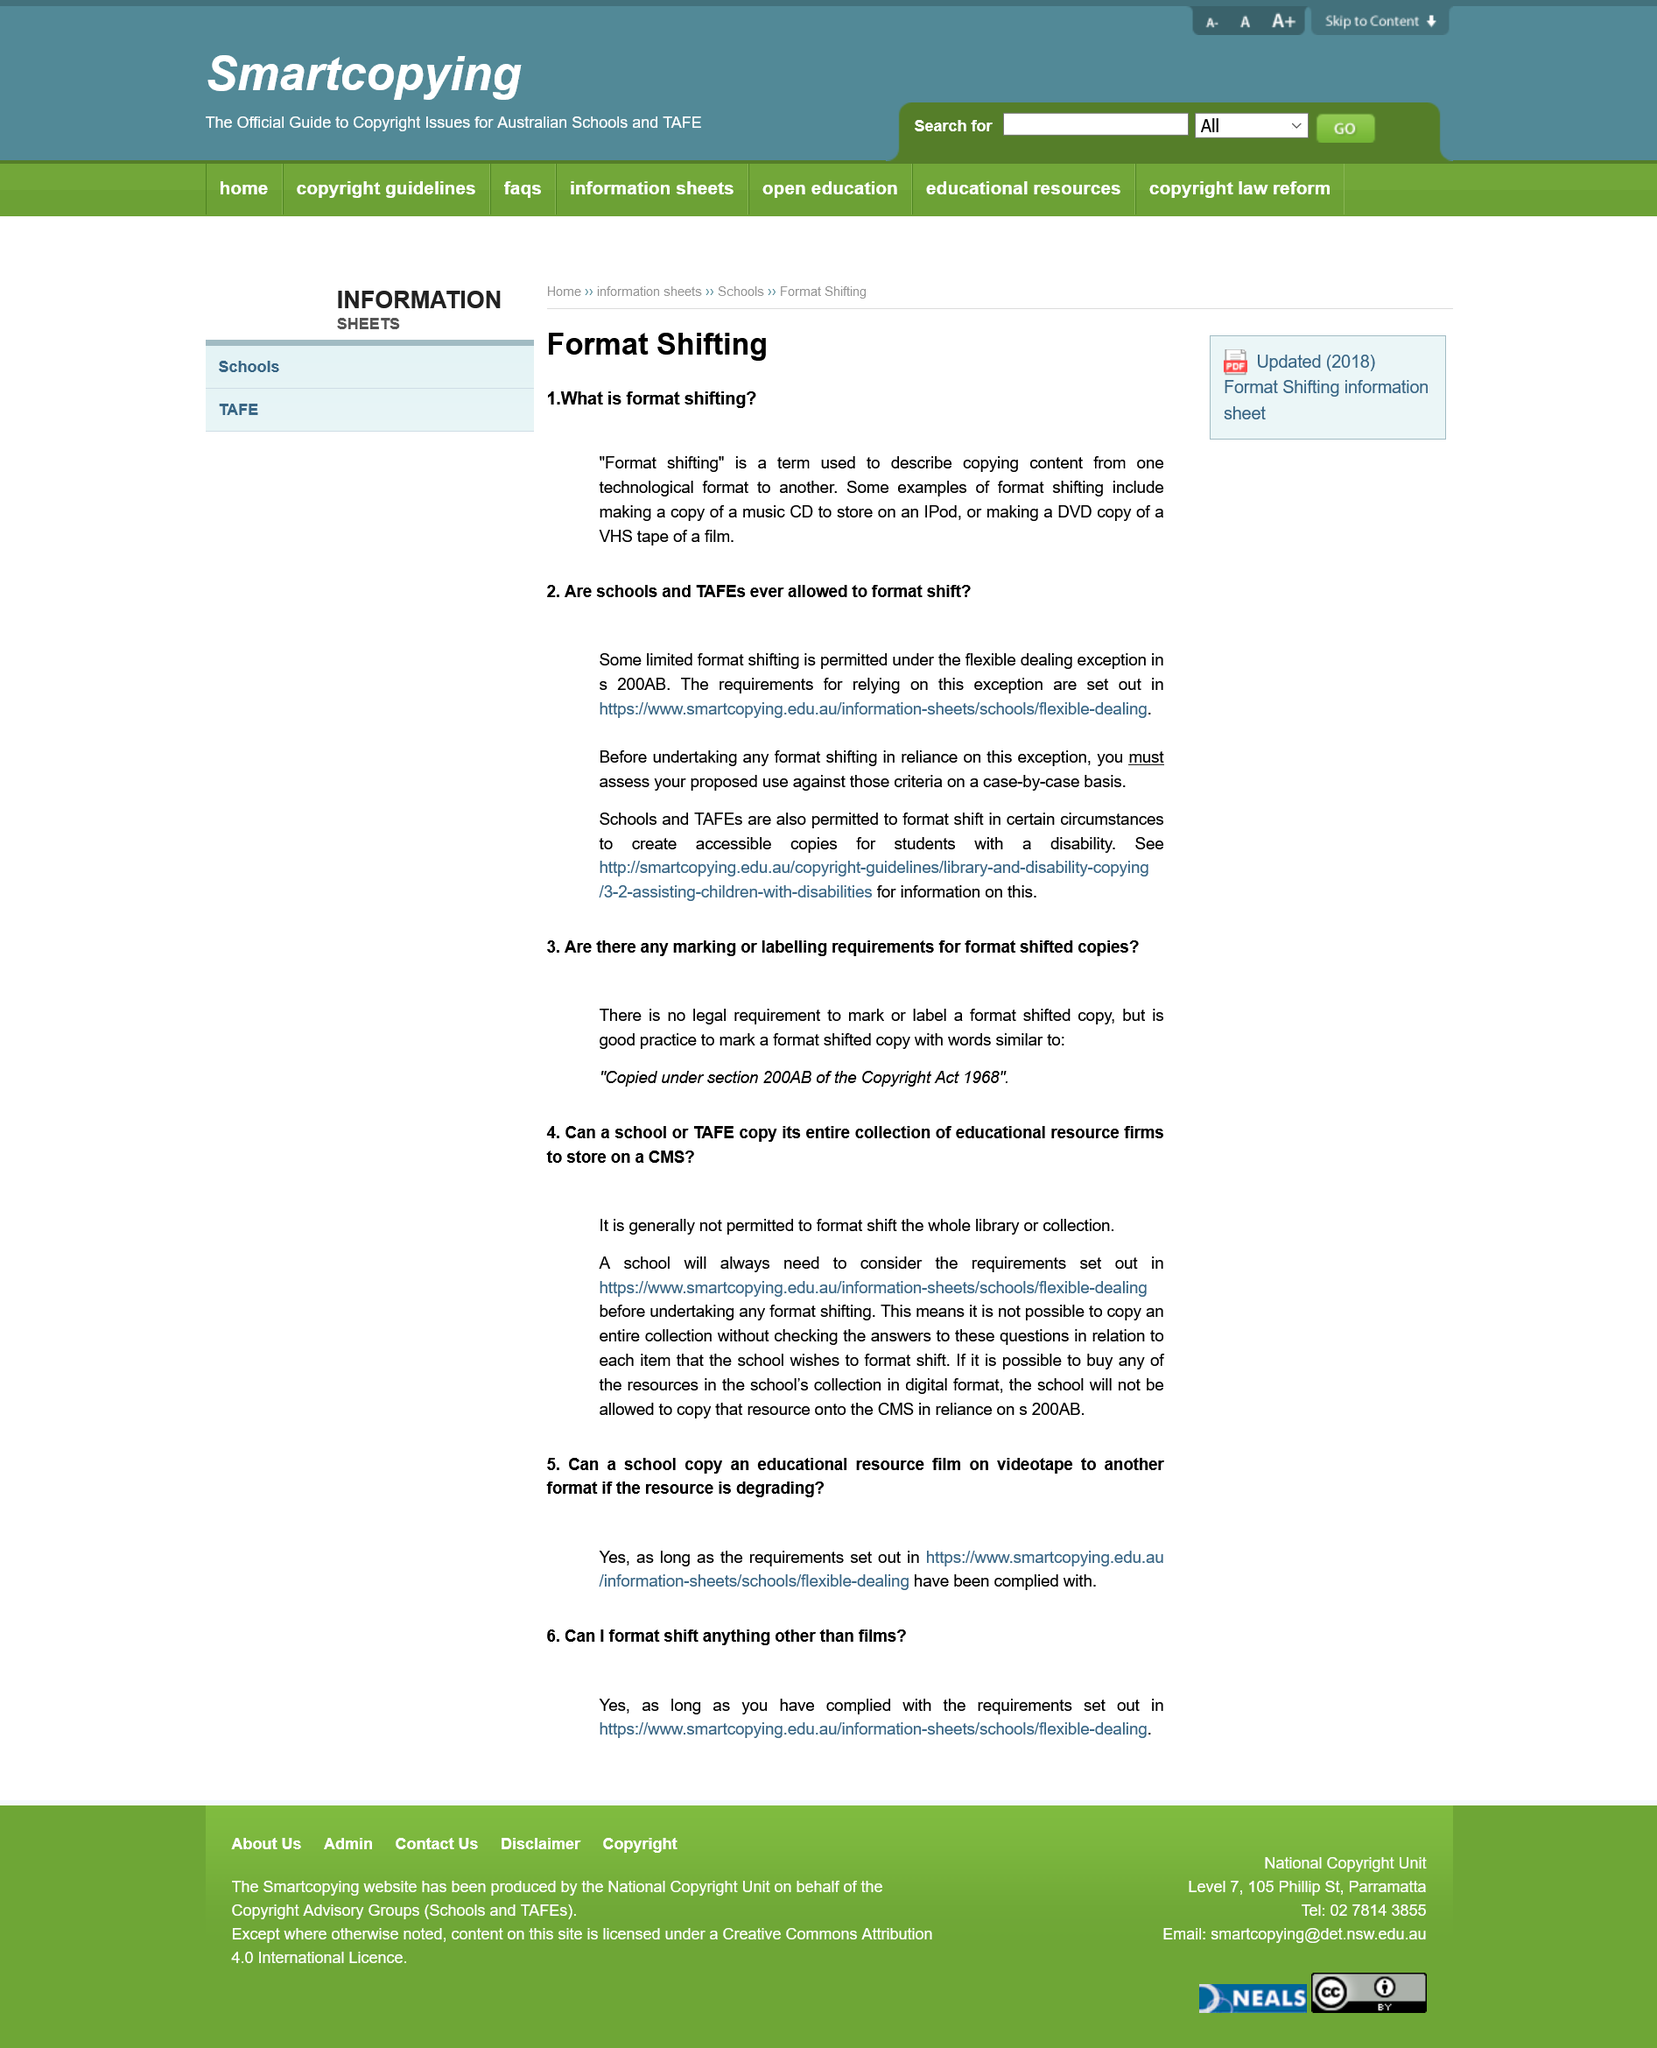Mention a couple of crucial points in this snapshot. Format shifting refers to the practice of moving media from one format to another, and it is not specific to music alone, but can also include visual mediums such as transferring VHS tapes to DVDs. Yes, copying music from a CD to store on an iPod is considered a type of format shifting. Under exception 200AB of the Copyright Act, schools are permitted to engage in limited format shifting, which refers to the act of making copies of copyrighted material for the purpose of private study or research. This exception allows schools to make copies of copyrighted material for educational purposes, as long as they do not violate any other provisions of the Copyright Act. 